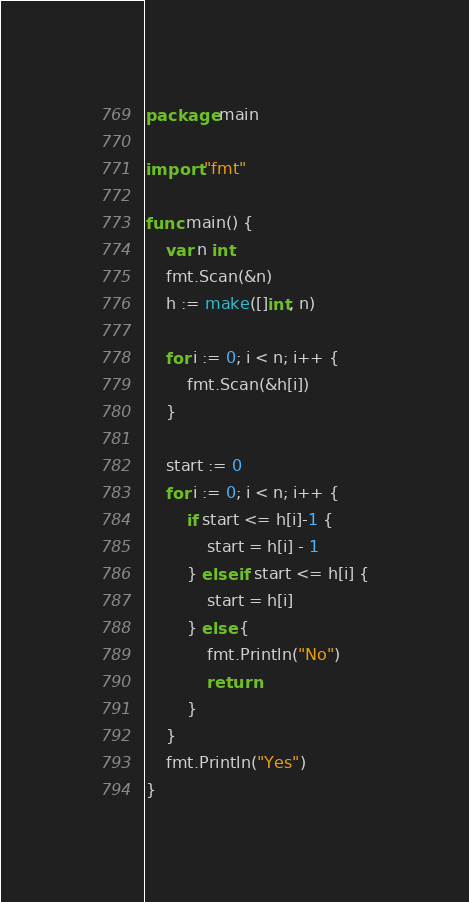Convert code to text. <code><loc_0><loc_0><loc_500><loc_500><_Go_>package main

import "fmt"

func main() {
	var n int
	fmt.Scan(&n)
	h := make([]int, n)

	for i := 0; i < n; i++ {
		fmt.Scan(&h[i])
	}

	start := 0
	for i := 0; i < n; i++ {
		if start <= h[i]-1 {
			start = h[i] - 1
		} else if start <= h[i] {
			start = h[i]
		} else {
			fmt.Println("No")
			return
		}
	}
	fmt.Println("Yes")
}
</code> 